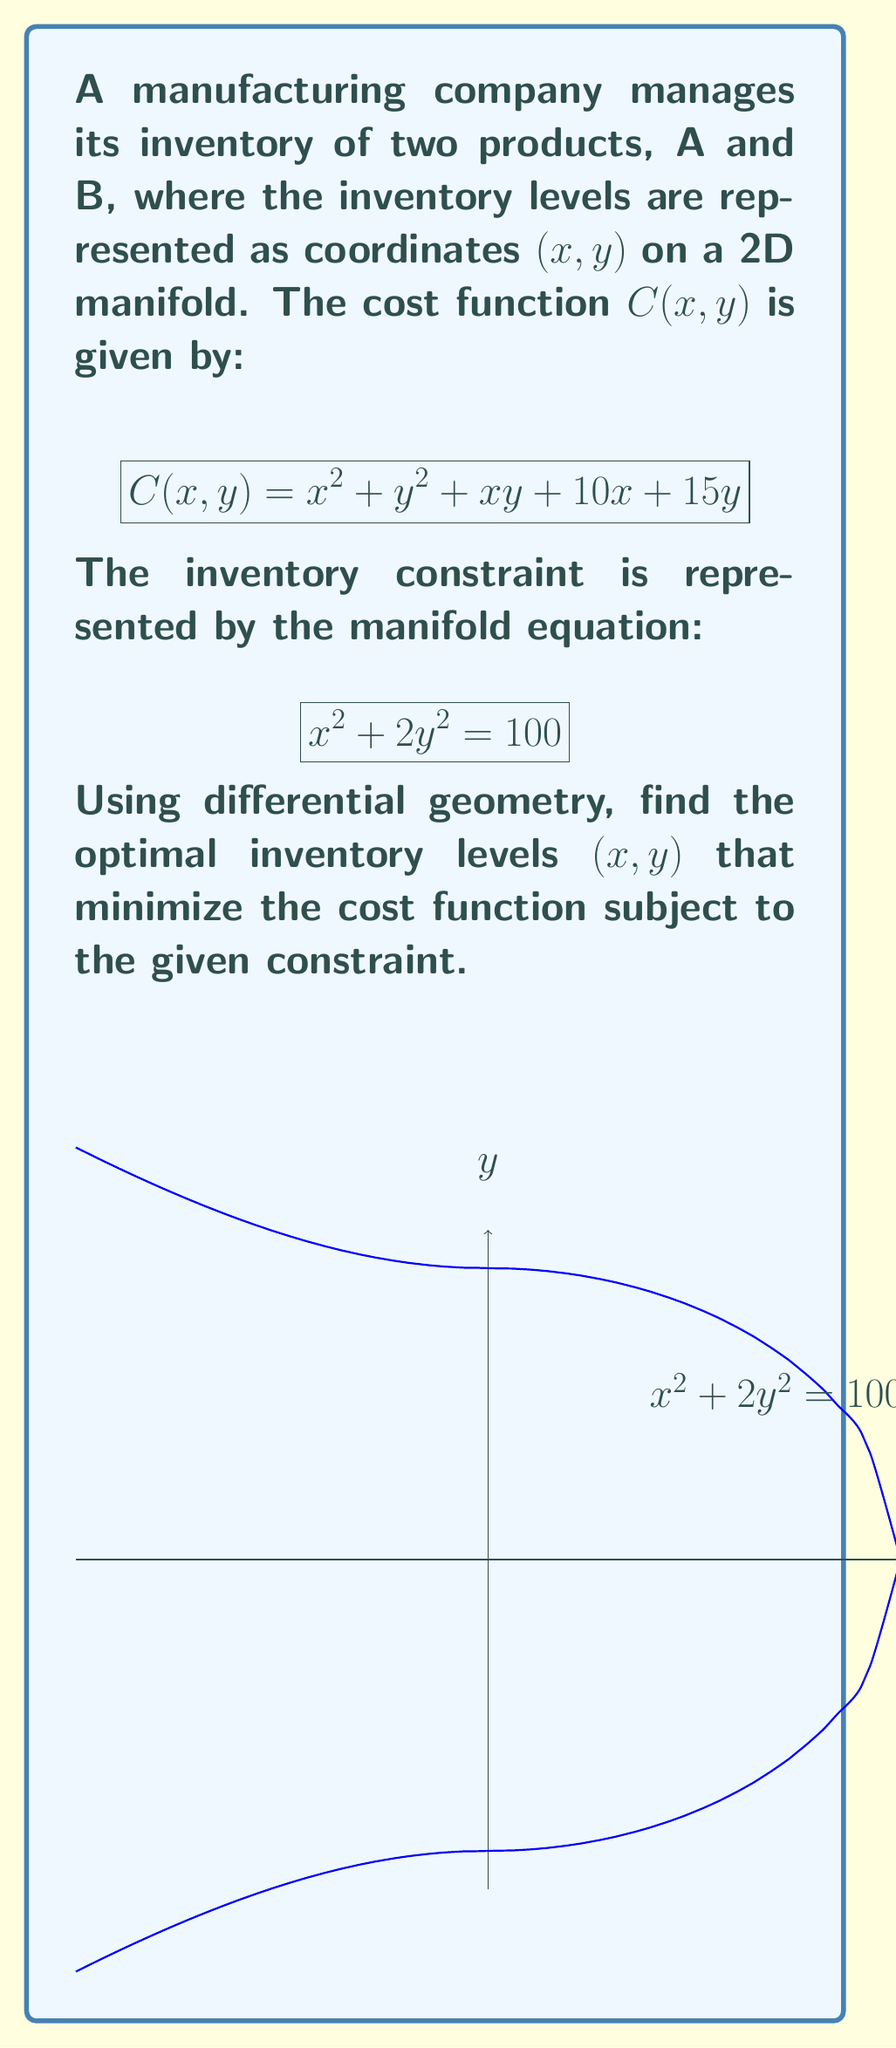Solve this math problem. To solve this problem, we'll use the method of Lagrange multipliers on the manifold:

1) First, we define the Lagrangian function:
   $$L(x, y, \lambda) = C(x, y) - \lambda(x^2 + 2y^2 - 100)$$

2) We calculate the partial derivatives and set them to zero:
   $$\frac{\partial L}{\partial x} = 2x + y + 10 - 2\lambda x = 0$$
   $$\frac{\partial L}{\partial y} = 2y + x + 15 - 4\lambda y = 0$$
   $$\frac{\partial L}{\partial \lambda} = x^2 + 2y^2 - 100 = 0$$

3) From the first equation:
   $$\lambda = \frac{2x + y + 10}{2x}$$

4) Substituting this into the second equation:
   $$2y + x + 15 - 4y\left(\frac{2x + y + 10}{2x}\right) = 0$$

5) Simplifying:
   $$2y + x + 15 - \frac{8xy + 4y^2 + 40y}{2x} = 0$$
   $$4xy + 2x^2 + 30x - 8xy - 4y^2 - 40y = 0$$
   $$2x^2 - 4xy - 4y^2 + 30x - 40y = 0$$

6) Using the constraint equation $x^2 + 2y^2 = 100$, we can eliminate $y^2$:
   $$2x^2 - 4xy - 2(100 - x^2) + 30x - 40y = 0$$
   $$4x^2 - 4xy + 30x - 40y - 200 = 0$$

7) We now have two equations with two unknowns:
   $$4x^2 - 4xy + 30x - 40y - 200 = 0$$
   $$x^2 + 2y^2 = 100$$

8) Solving this system numerically (as an exact solution is complex), we get:
   $$x \approx 8.16$$
   $$y \approx 4.90$$

These values satisfy both equations and represent the optimal inventory levels.
Answer: $(8.16, 4.90)$ 